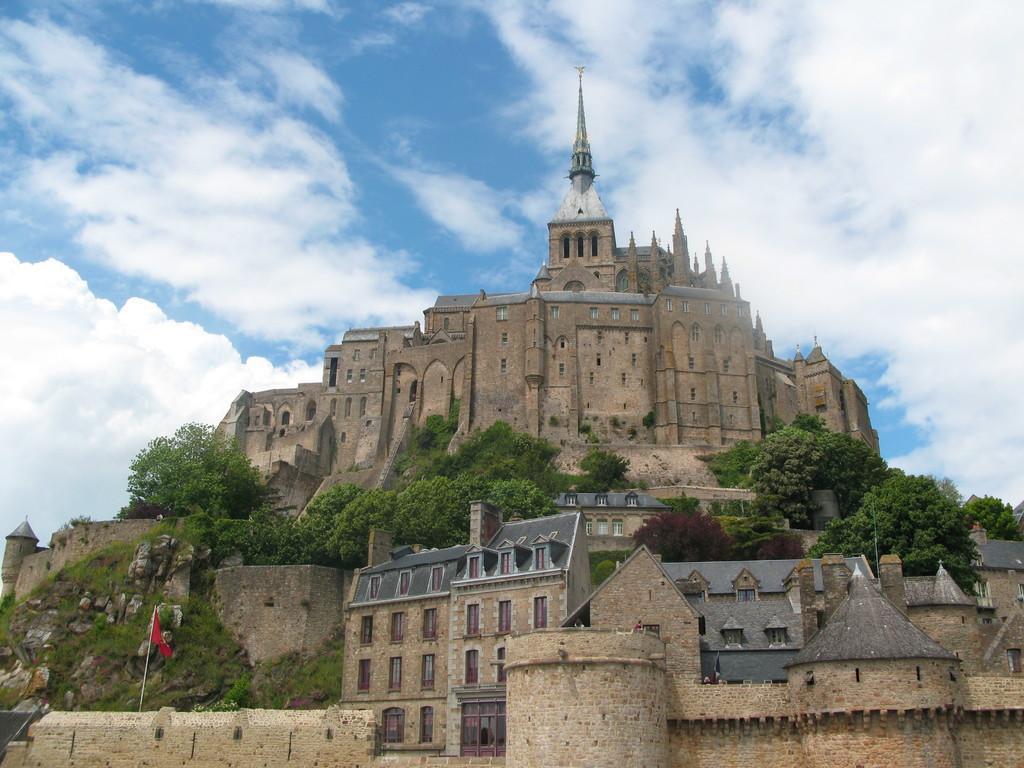Describe this image in one or two sentences. In this image there is a castle on the hill. There are trees and plants on the hill. In the bottom left there is a flag on the wall. At the top there is the sky. 